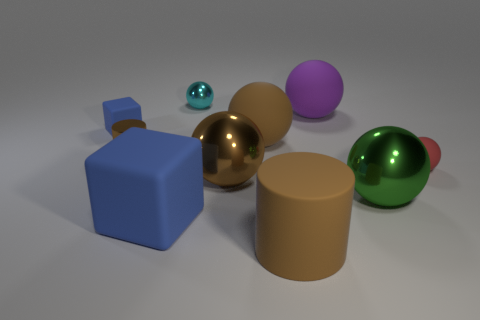There is a purple object that is the same material as the big cube; what shape is it?
Your answer should be very brief. Sphere. Are there any other things that have the same shape as the tiny brown metallic thing?
Your answer should be very brief. Yes. There is a small shiny cylinder; what number of big objects are in front of it?
Your response must be concise. 4. Are there any yellow metal spheres?
Your answer should be compact. No. There is a cylinder behind the brown metallic object to the right of the tiny thing behind the tiny blue block; what is its color?
Ensure brevity in your answer.  Brown. There is a big brown rubber object that is in front of the tiny matte sphere; are there any tiny balls in front of it?
Offer a terse response. No. There is a cylinder that is on the left side of the large cube; is it the same color as the tiny rubber object to the left of the large cube?
Make the answer very short. No. How many red matte objects are the same size as the purple object?
Make the answer very short. 0. There is a brown matte ball left of the matte cylinder; is its size the same as the big blue rubber thing?
Offer a terse response. Yes. The large purple matte thing has what shape?
Your answer should be compact. Sphere. 